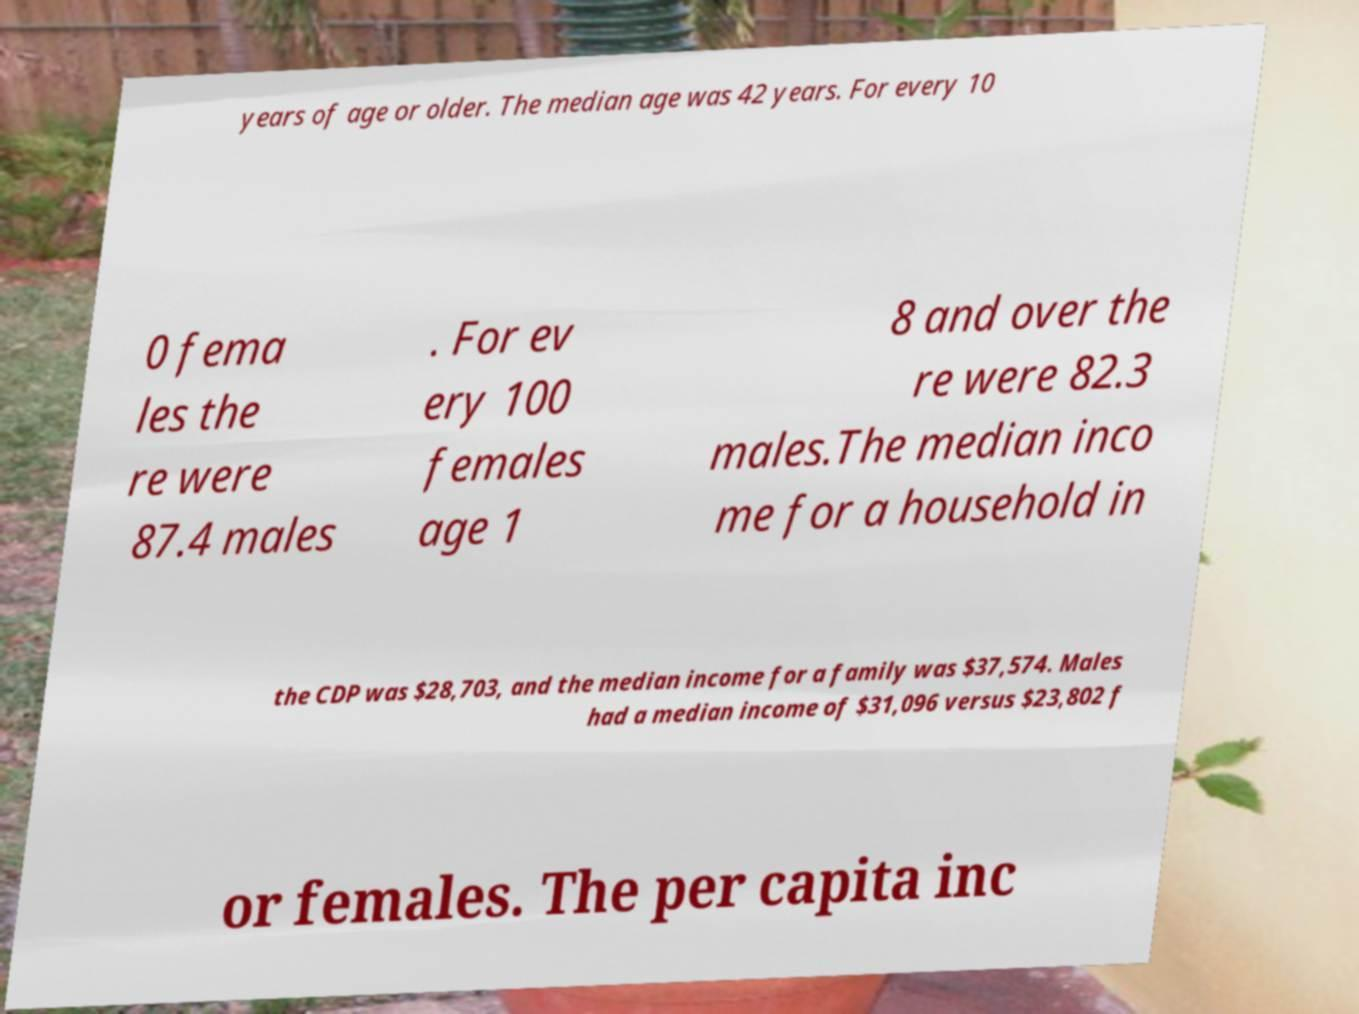I need the written content from this picture converted into text. Can you do that? years of age or older. The median age was 42 years. For every 10 0 fema les the re were 87.4 males . For ev ery 100 females age 1 8 and over the re were 82.3 males.The median inco me for a household in the CDP was $28,703, and the median income for a family was $37,574. Males had a median income of $31,096 versus $23,802 f or females. The per capita inc 